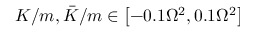<formula> <loc_0><loc_0><loc_500><loc_500>K / m , \bar { K } / m \in \left [ - 0 . 1 \Omega ^ { 2 } , 0 . 1 \Omega ^ { 2 } \right ]</formula> 